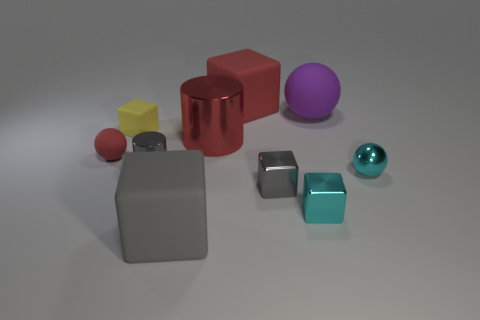Subtract all large red matte blocks. How many blocks are left? 4 Subtract 1 balls. How many balls are left? 2 Subtract all yellow cubes. How many cubes are left? 4 Subtract all yellow blocks. Subtract all red balls. How many blocks are left? 4 Subtract all spheres. How many objects are left? 7 Add 8 gray metal cylinders. How many gray metal cylinders exist? 9 Subtract 0 blue cylinders. How many objects are left? 10 Subtract all tiny yellow matte things. Subtract all small things. How many objects are left? 3 Add 2 red rubber balls. How many red rubber balls are left? 3 